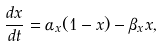<formula> <loc_0><loc_0><loc_500><loc_500>\frac { d x } { d t } & = \alpha _ { x } ( 1 - x ) - \beta _ { x } x ,</formula> 